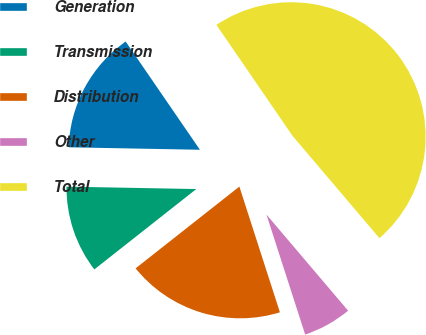<chart> <loc_0><loc_0><loc_500><loc_500><pie_chart><fcel>Generation<fcel>Transmission<fcel>Distribution<fcel>Other<fcel>Total<nl><fcel>15.13%<fcel>10.92%<fcel>19.34%<fcel>6.24%<fcel>48.36%<nl></chart> 